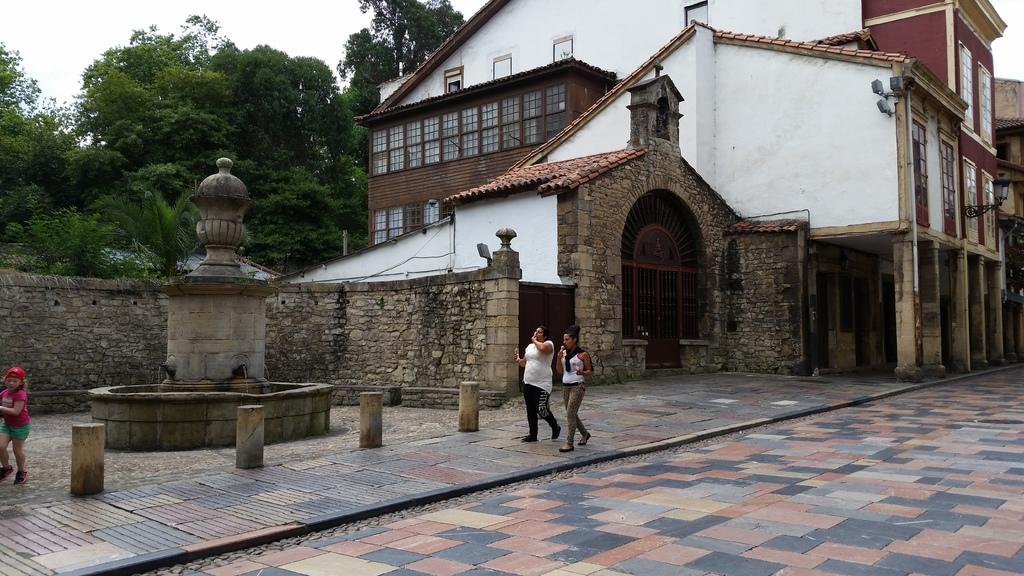What type of vegetation can be seen in the image? There are trees in the image. What part of the natural environment is visible in the image? The sky is visible in the image. Can you describe the people in the image? There are people in the image. What type of structure is present in the image? There is a water fountain and a building in the image. What architectural feature can be seen in the image? There is a grille and pillars in the image. What artificial light source is present in the image? There is a light in the image. How many girls are taking a bath in the image? There are no girls or baths present in the image. What time of day is depicted in the image? The time of day cannot be determined from the image, as there is no specific indication of day or night. 